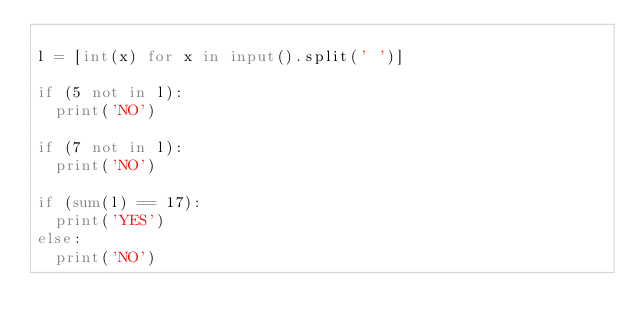<code> <loc_0><loc_0><loc_500><loc_500><_Python_>
l = [int(x) for x in input().split(' ')]

if (5 not in l):
  print('NO')

if (7 not in l):
  print('NO')

if (sum(l) == 17):
  print('YES')
else:
  print('NO')</code> 